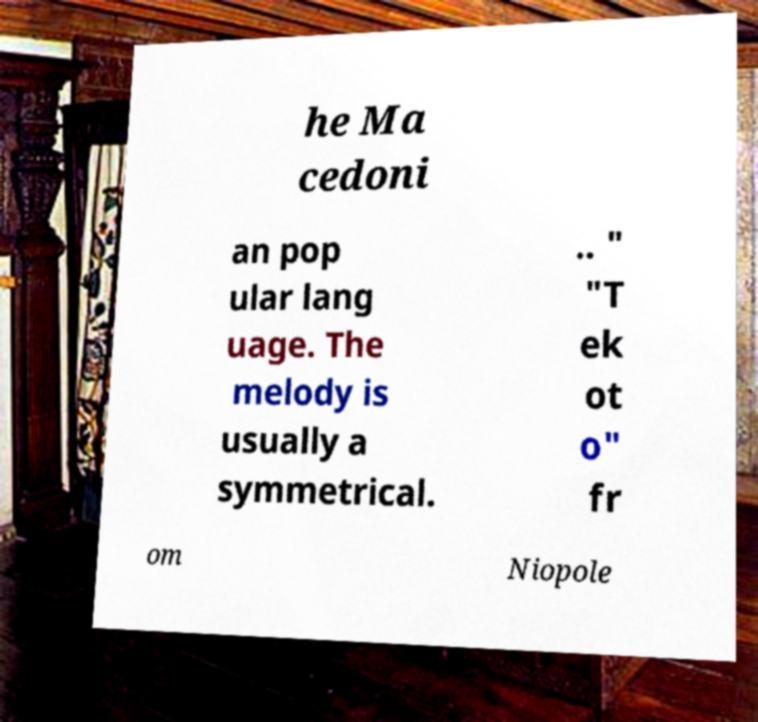I need the written content from this picture converted into text. Can you do that? he Ma cedoni an pop ular lang uage. The melody is usually a symmetrical. .. " "T ek ot o" fr om Niopole 